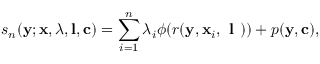<formula> <loc_0><loc_0><loc_500><loc_500>s _ { n } ( { y } ; { x } , \lambda , l , c ) = \sum _ { i = 1 } ^ { n } \lambda _ { i } \phi ( r ( { y } , { x } _ { i } , l ) ) + p ( { y } , c ) ,</formula> 